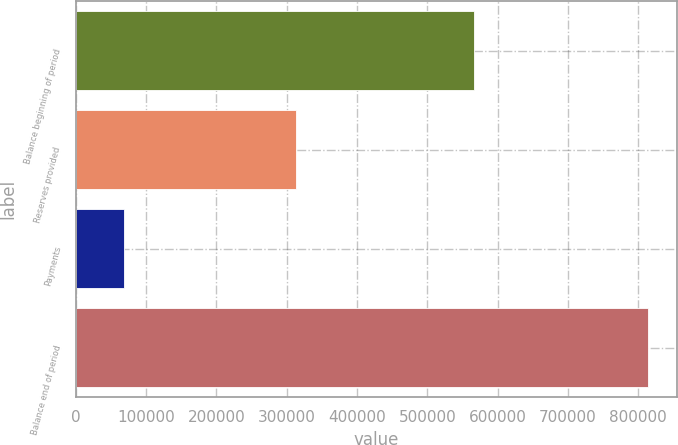<chart> <loc_0><loc_0><loc_500><loc_500><bar_chart><fcel>Balance beginning of period<fcel>Reserves provided<fcel>Payments<fcel>Balance end of period<nl><fcel>566693<fcel>313606<fcel>68972<fcel>813841<nl></chart> 